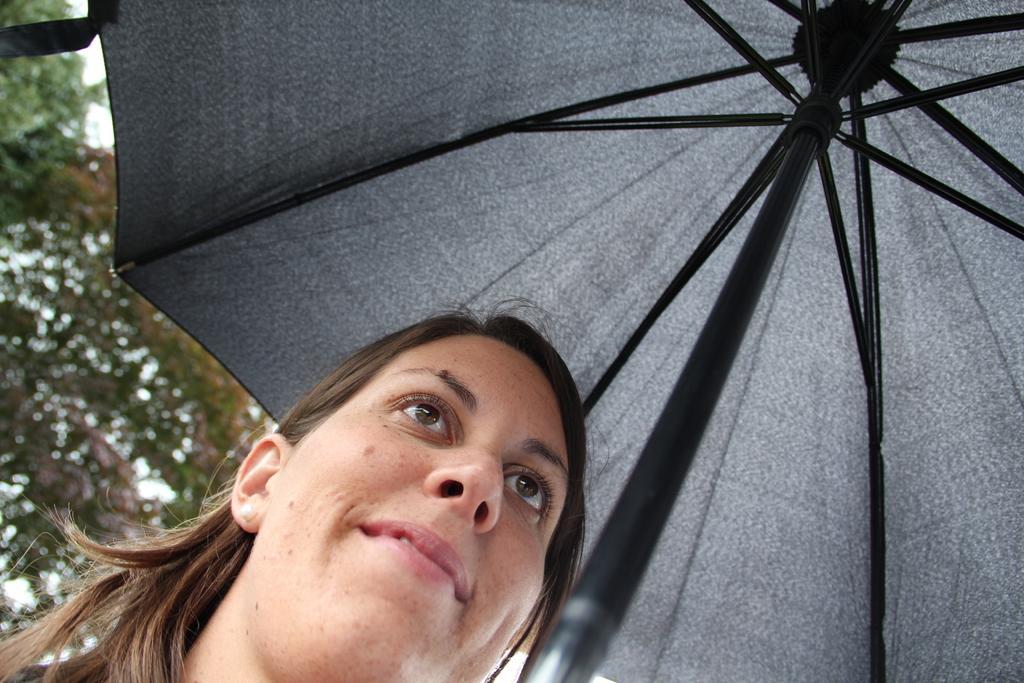Can you describe this image briefly? There is a woman holding an umbrella and smiling. In the background there is a tree. 